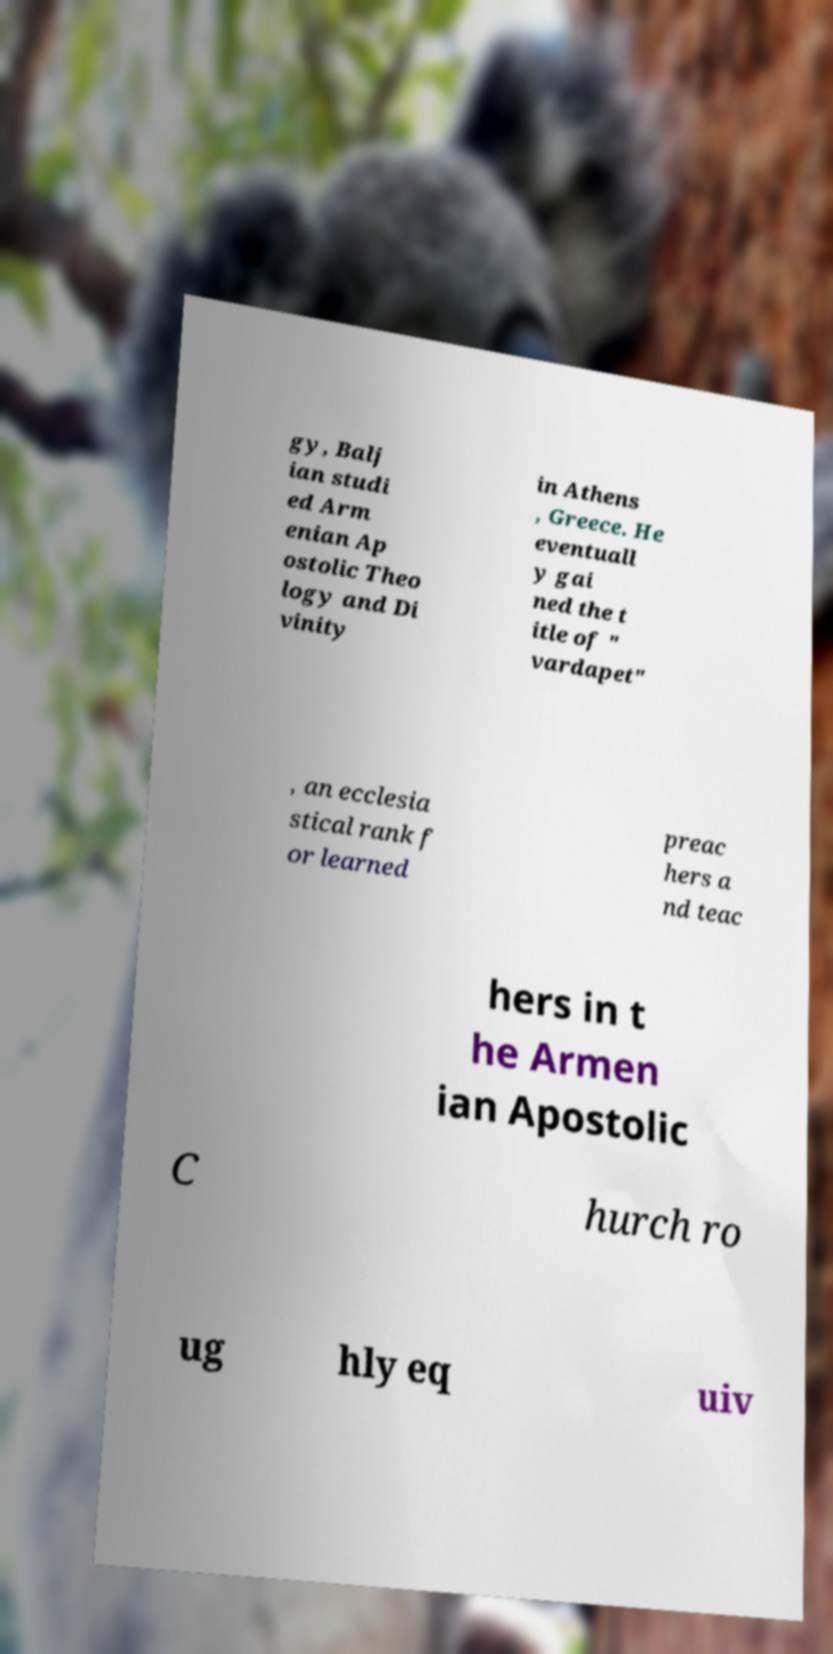For documentation purposes, I need the text within this image transcribed. Could you provide that? gy, Balj ian studi ed Arm enian Ap ostolic Theo logy and Di vinity in Athens , Greece. He eventuall y gai ned the t itle of " vardapet" , an ecclesia stical rank f or learned preac hers a nd teac hers in t he Armen ian Apostolic C hurch ro ug hly eq uiv 